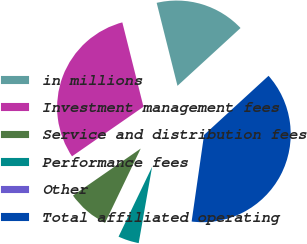Convert chart to OTSL. <chart><loc_0><loc_0><loc_500><loc_500><pie_chart><fcel>in millions<fcel>Investment management fees<fcel>Service and distribution fees<fcel>Performance fees<fcel>Other<fcel>Total affiliated operating<nl><fcel>17.1%<fcel>30.74%<fcel>8.22%<fcel>4.36%<fcel>0.5%<fcel>39.08%<nl></chart> 